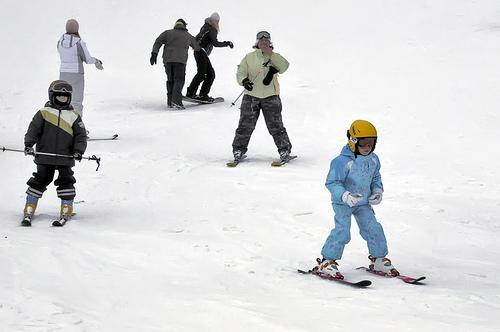What is the likely relationship of the woman to the kids?

Choices:
A) mother
B) sister
C) school principal
D) great grandmother mother 